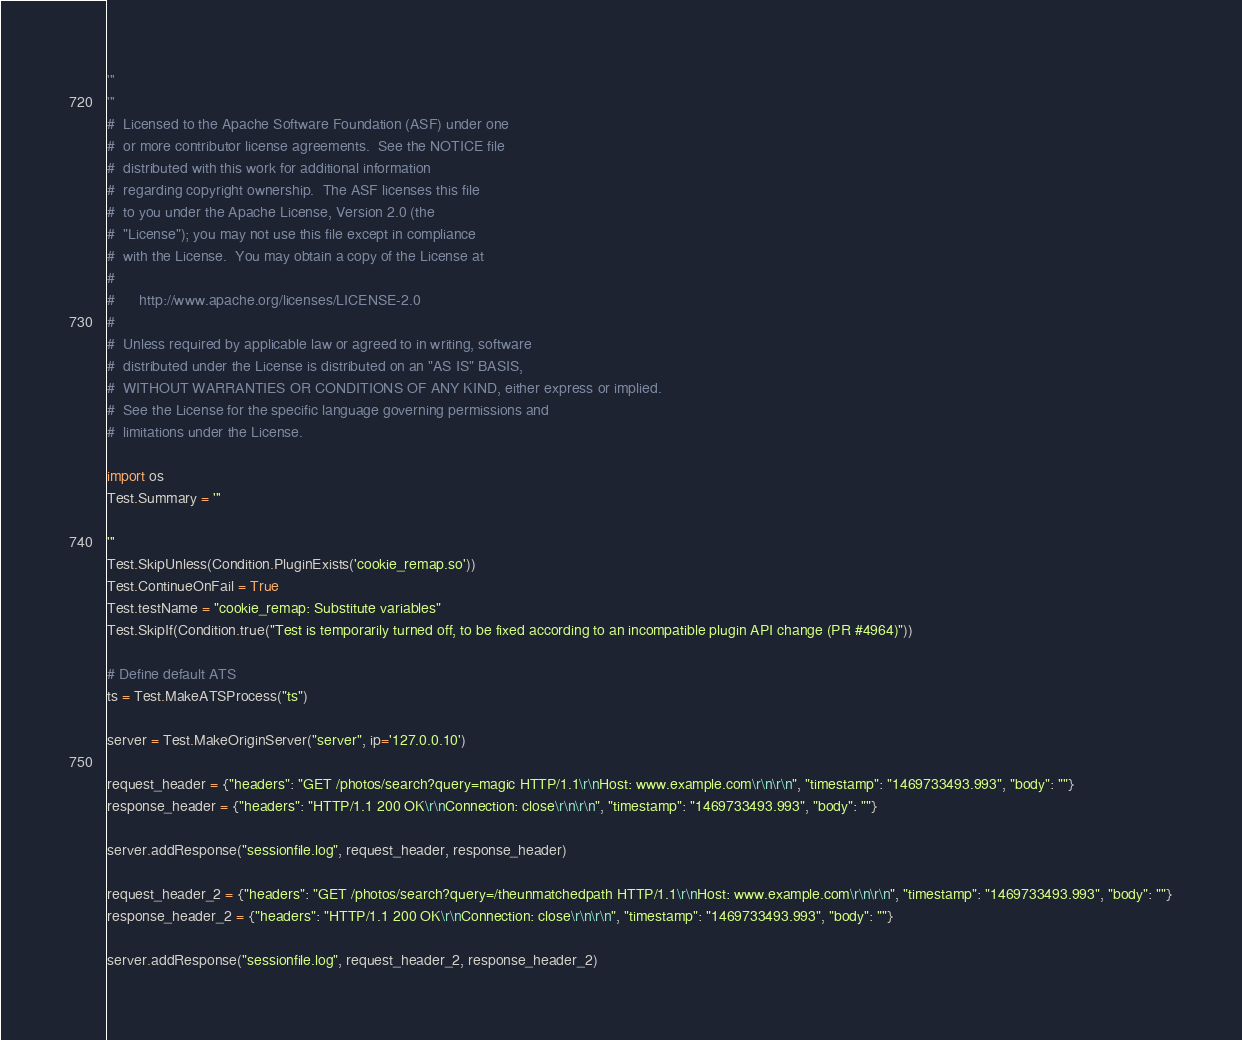Convert code to text. <code><loc_0><loc_0><loc_500><loc_500><_Python_>'''
'''
#  Licensed to the Apache Software Foundation (ASF) under one
#  or more contributor license agreements.  See the NOTICE file
#  distributed with this work for additional information
#  regarding copyright ownership.  The ASF licenses this file
#  to you under the Apache License, Version 2.0 (the
#  "License"); you may not use this file except in compliance
#  with the License.  You may obtain a copy of the License at
#
#      http://www.apache.org/licenses/LICENSE-2.0
#
#  Unless required by applicable law or agreed to in writing, software
#  distributed under the License is distributed on an "AS IS" BASIS,
#  WITHOUT WARRANTIES OR CONDITIONS OF ANY KIND, either express or implied.
#  See the License for the specific language governing permissions and
#  limitations under the License.

import os
Test.Summary = '''

'''
Test.SkipUnless(Condition.PluginExists('cookie_remap.so'))
Test.ContinueOnFail = True
Test.testName = "cookie_remap: Substitute variables"
Test.SkipIf(Condition.true("Test is temporarily turned off, to be fixed according to an incompatible plugin API change (PR #4964)"))

# Define default ATS
ts = Test.MakeATSProcess("ts")

server = Test.MakeOriginServer("server", ip='127.0.0.10')

request_header = {"headers": "GET /photos/search?query=magic HTTP/1.1\r\nHost: www.example.com\r\n\r\n", "timestamp": "1469733493.993", "body": ""}
response_header = {"headers": "HTTP/1.1 200 OK\r\nConnection: close\r\n\r\n", "timestamp": "1469733493.993", "body": ""}

server.addResponse("sessionfile.log", request_header, response_header)

request_header_2 = {"headers": "GET /photos/search?query=/theunmatchedpath HTTP/1.1\r\nHost: www.example.com\r\n\r\n", "timestamp": "1469733493.993", "body": ""}
response_header_2 = {"headers": "HTTP/1.1 200 OK\r\nConnection: close\r\n\r\n", "timestamp": "1469733493.993", "body": ""}

server.addResponse("sessionfile.log", request_header_2, response_header_2)
</code> 